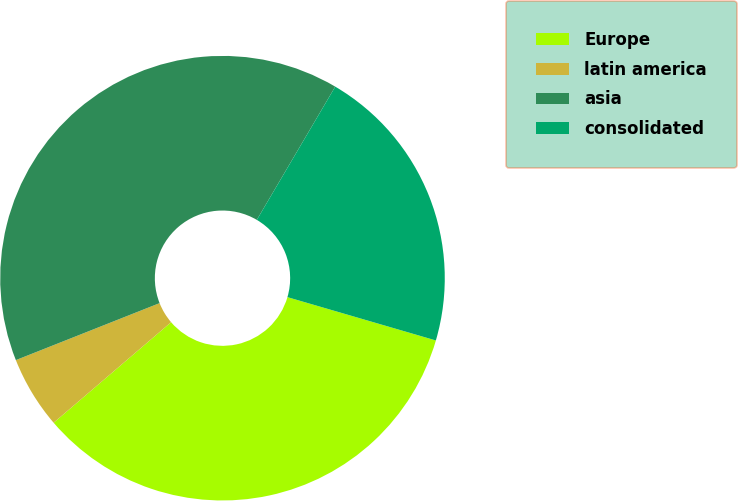<chart> <loc_0><loc_0><loc_500><loc_500><pie_chart><fcel>Europe<fcel>latin america<fcel>asia<fcel>consolidated<nl><fcel>34.21%<fcel>5.26%<fcel>39.47%<fcel>21.05%<nl></chart> 